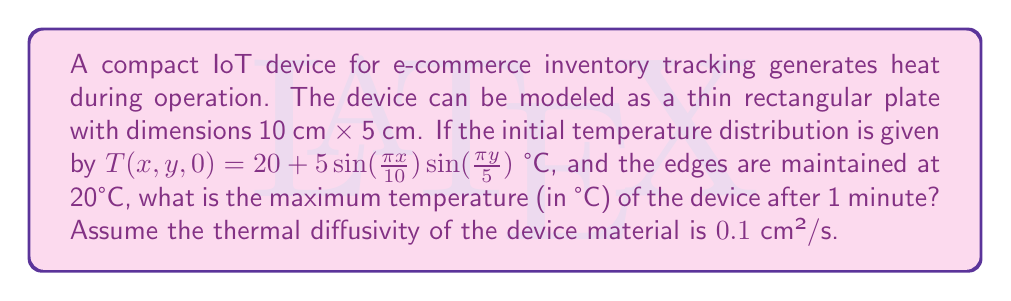Solve this math problem. To solve this problem, we'll use the 2D heat equation and its solution for a rectangular plate with fixed boundary conditions:

1) The 2D heat equation is:
   $$\frac{\partial T}{\partial t} = \alpha(\frac{\partial^2 T}{\partial x^2} + \frac{\partial^2 T}{\partial y^2})$$
   where $\alpha$ is the thermal diffusivity.

2) The solution for a rectangular plate with dimensions $L_x$ and $L_y$ is:
   $$T(x,y,t) = 20 + \sum_{m=1}^{\infty}\sum_{n=1}^{\infty}A_{mn}\sin(\frac{m\pi x}{L_x})\sin(\frac{n\pi y}{L_y})e^{-\alpha(\frac{m^2\pi^2}{L_x^2}+\frac{n^2\pi^2}{L_y^2})t}$$

3) Comparing with the initial condition, we see that only the term with $m=1$ and $n=1$ is non-zero, with $A_{11} = 5$. So our solution simplifies to:
   $$T(x,y,t) = 20 + 5\sin(\frac{\pi x}{10})\sin(\frac{\pi y}{5})e^{-0.1(\frac{\pi^2}{100}+\frac{\pi^2}{25})t}$$

4) After 1 minute (60 seconds), the temperature distribution is:
   $$T(x,y,60) = 20 + 5\sin(\frac{\pi x}{10})\sin(\frac{\pi y}{5})e^{-0.1(\frac{\pi^2}{100}+\frac{\pi^2}{25})60}$$

5) The exponential term evaluates to:
   $$e^{-0.1(\frac{\pi^2}{100}+\frac{\pi^2}{25})60} \approx 0.0416$$

6) So the temperature distribution after 1 minute is:
   $$T(x,y,60) \approx 20 + 0.208\sin(\frac{\pi x}{10})\sin(\frac{\pi y}{5})$$

7) The maximum of this function occurs at the center of the plate $(x=5, y=2.5)$, where both sine terms equal 1.

8) Therefore, the maximum temperature is:
   $$T_{max} = 20 + 0.208 = 20.208°C$$
Answer: 20.208°C 